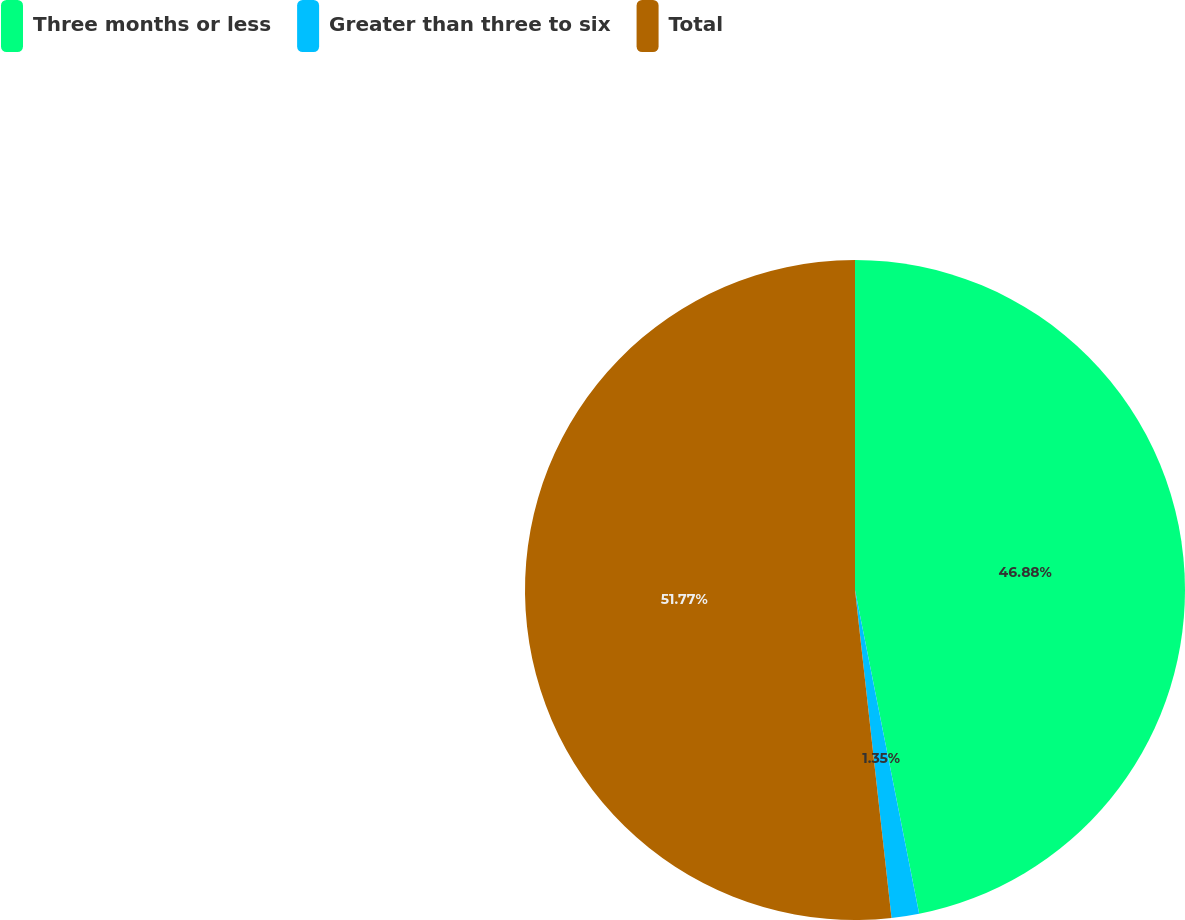<chart> <loc_0><loc_0><loc_500><loc_500><pie_chart><fcel>Three months or less<fcel>Greater than three to six<fcel>Total<nl><fcel>46.88%<fcel>1.35%<fcel>51.76%<nl></chart> 